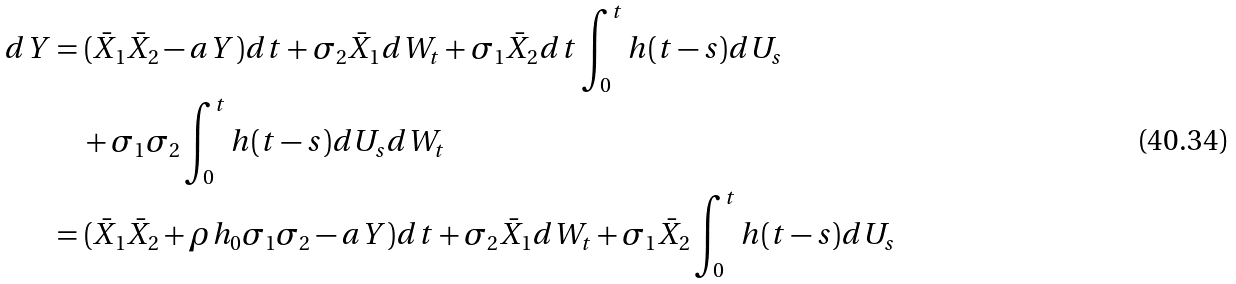Convert formula to latex. <formula><loc_0><loc_0><loc_500><loc_500>d Y & = ( \bar { X } _ { 1 } \bar { X } _ { 2 } - a Y ) d t + \sigma _ { 2 } \bar { X } _ { 1 } d W _ { t } + \sigma _ { 1 } \bar { X } _ { 2 } d t \int _ { 0 } ^ { t } h ( t - s ) d U _ { s } \\ & \quad + \sigma _ { 1 } \sigma _ { 2 } \int _ { 0 } ^ { t } h ( t - s ) d U _ { s } d W _ { t } \\ & = ( \bar { X } _ { 1 } \bar { X } _ { 2 } + \rho h _ { 0 } \sigma _ { 1 } \sigma _ { 2 } - a Y ) d t + \sigma _ { 2 } \bar { X } _ { 1 } d W _ { t } + \sigma _ { 1 } \bar { X } _ { 2 } \int _ { 0 } ^ { t } h ( t - s ) d U _ { s }</formula> 